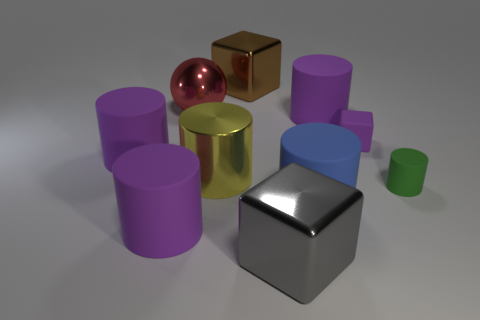How many purple cylinders must be subtracted to get 1 purple cylinders? 2 Subtract all green balls. How many purple cylinders are left? 3 Subtract all small green cylinders. How many cylinders are left? 5 Subtract all green cylinders. How many cylinders are left? 5 Subtract all cyan cubes. Subtract all purple cylinders. How many cubes are left? 3 Add 8 blue things. How many blue things are left? 9 Add 9 big brown metallic blocks. How many big brown metallic blocks exist? 10 Subtract 1 brown cubes. How many objects are left? 9 Subtract all balls. How many objects are left? 9 Subtract all small objects. Subtract all tiny cylinders. How many objects are left? 7 